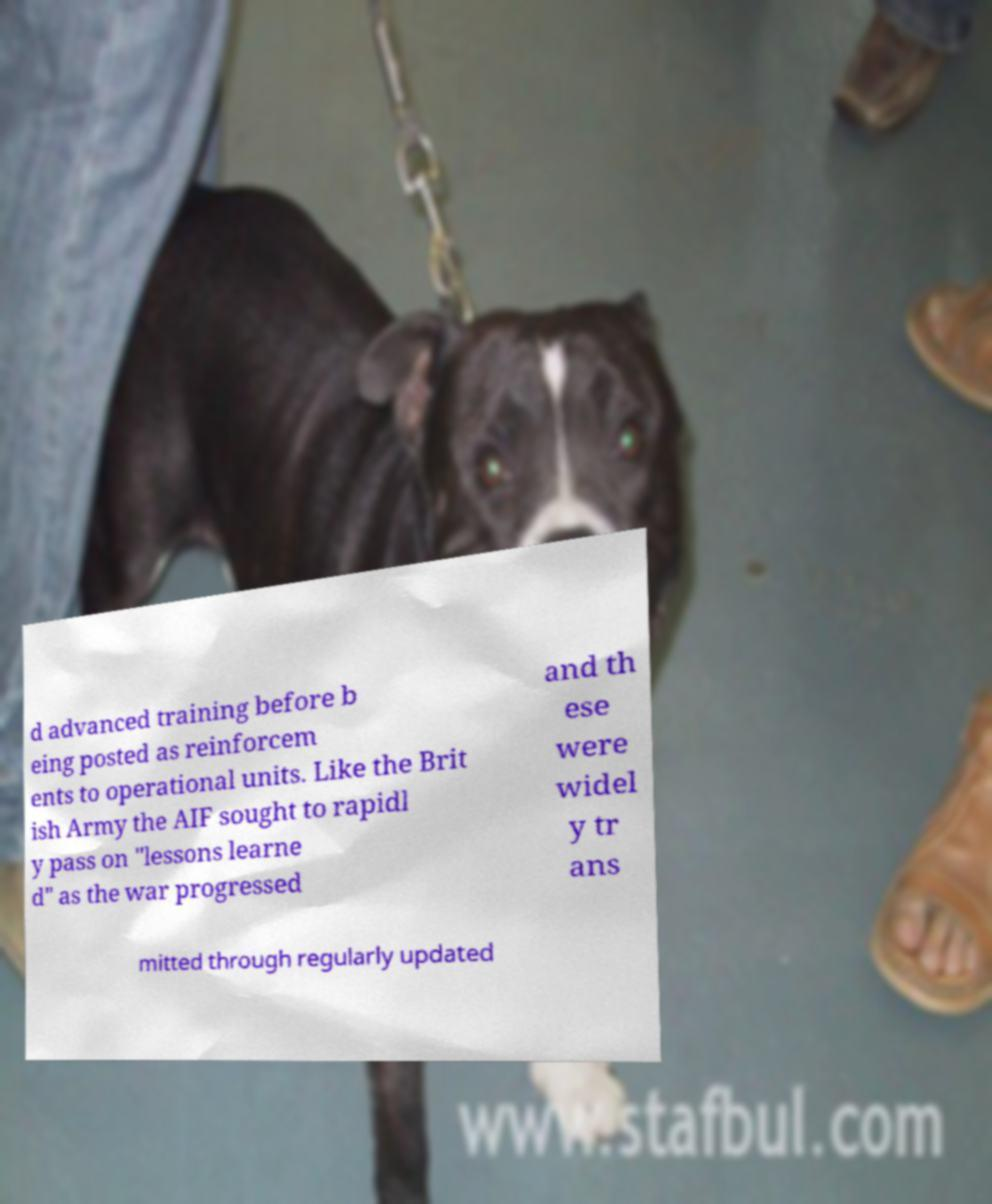Could you extract and type out the text from this image? d advanced training before b eing posted as reinforcem ents to operational units. Like the Brit ish Army the AIF sought to rapidl y pass on "lessons learne d" as the war progressed and th ese were widel y tr ans mitted through regularly updated 